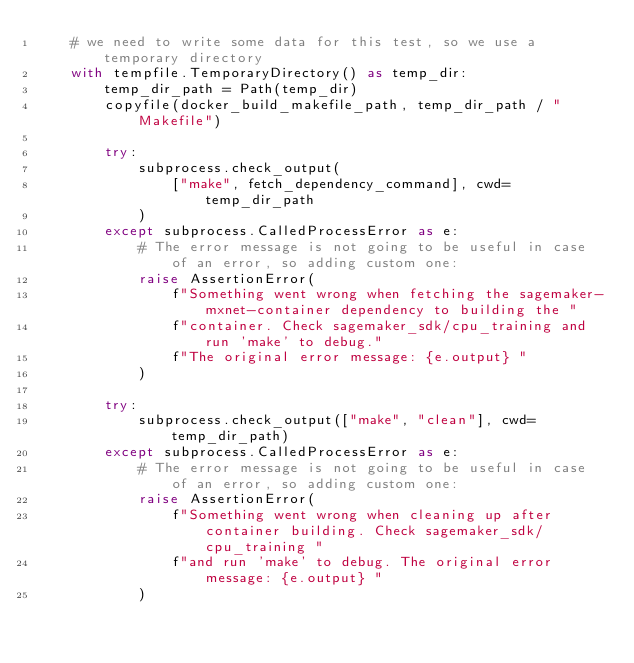Convert code to text. <code><loc_0><loc_0><loc_500><loc_500><_Python_>    # we need to write some data for this test, so we use a temporary directory
    with tempfile.TemporaryDirectory() as temp_dir:
        temp_dir_path = Path(temp_dir)
        copyfile(docker_build_makefile_path, temp_dir_path / "Makefile")

        try:
            subprocess.check_output(
                ["make", fetch_dependency_command], cwd=temp_dir_path
            )
        except subprocess.CalledProcessError as e:
            # The error message is not going to be useful in case of an error, so adding custom one:
            raise AssertionError(
                f"Something went wrong when fetching the sagemaker-mxnet-container dependency to building the "
                f"container. Check sagemaker_sdk/cpu_training and run 'make' to debug."
                f"The original error message: {e.output} "
            )

        try:
            subprocess.check_output(["make", "clean"], cwd=temp_dir_path)
        except subprocess.CalledProcessError as e:
            # The error message is not going to be useful in case of an error, so adding custom one:
            raise AssertionError(
                f"Something went wrong when cleaning up after container building. Check sagemaker_sdk/cpu_training "
                f"and run 'make' to debug. The original error message: {e.output} "
            )
</code> 